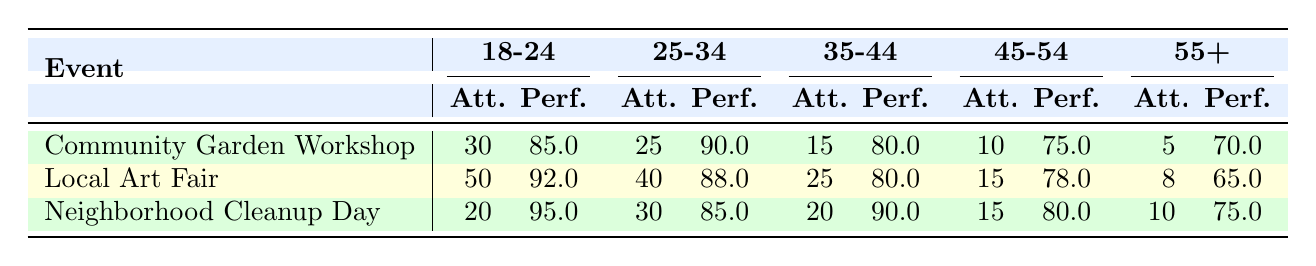What is the attendance for the Local Art Fair in the 18-24 age group? The table shows that for the Local Art Fair, the attendance for the 18-24 age group is listed directly under that event: 50.
Answer: 50 Which event had the highest performance score for the age group 35-44? Looking at the performance scores for the 35-44 age group across all events, the scores are: Community Garden Workshop (80), Local Art Fair (80), and Neighborhood Cleanup Day (90). The Neighborhood Cleanup Day has the highest score of 90.
Answer: Neighborhood Cleanup Day What is the total attendance of all events for the age group 45-54? The attendance for the age group 45-54 is as follows: Community Garden Workshop (10), Local Art Fair (15), and Neighborhood Cleanup Day (15). Summing these gives us 10 + 15 + 15 = 40.
Answer: 40 Is the performance score of the Neighborhood Cleanup Day for the 18-24 age group greater than 90? The performance score for the 18-24 age group in the Neighborhood Cleanup Day is given as 95. Since 95 is greater than 90, the answer is yes.
Answer: Yes What is the average attendance for participants aged 55 and older across all events? The attendance for the 55+ age group for each event is: Community Garden Workshop (5), Local Art Fair (8), and Neighborhood Cleanup Day (10). To find the average, we sum these values: 5 + 8 + 10 = 23, and divide by the number of events (3), giving us an average of 23/3 = 7.67.
Answer: 7.67 Which age group had the lowest attendance at the Community Garden Workshop? The age group attendance for the Community Garden Workshop is: 18-24 (30), 25-34 (25), 35-44 (15), 45-54 (10), and 55+ (5). The lowest attendance is for the 55+ age group, which had 5 participants.
Answer: 55+ How does the performance score for the Local Art Fair compare to the Neighborhood Cleanup Day for the 25-34 age group? For the Local Art Fair, the performance score for the 25-34 age group is 88, while for the Neighborhood Cleanup Day, it is 85. Comparing these, 88 is greater than 85.
Answer: Local Art Fair's score is higher What is the difference in performance scores between the Neighborhood Cleanup Day and the Community Garden Workshop for the 45-54 age group? The performance score for the Neighborhood Cleanup Day is 80 and for the Community Garden Workshop is 75 for the 45-54 group. The difference is 80 - 75 = 5.
Answer: 5 